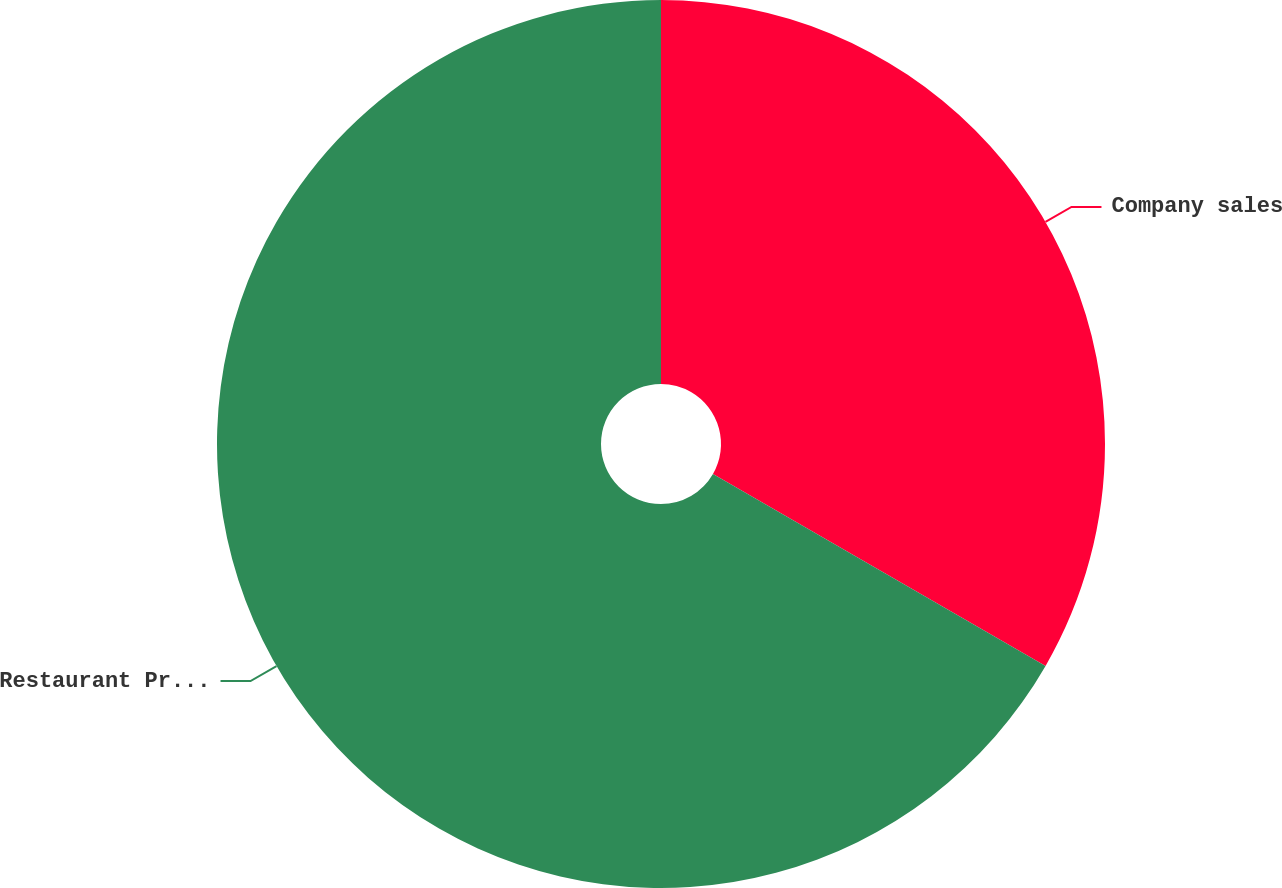Convert chart. <chart><loc_0><loc_0><loc_500><loc_500><pie_chart><fcel>Company sales<fcel>Restaurant Profit<nl><fcel>33.33%<fcel>66.67%<nl></chart> 